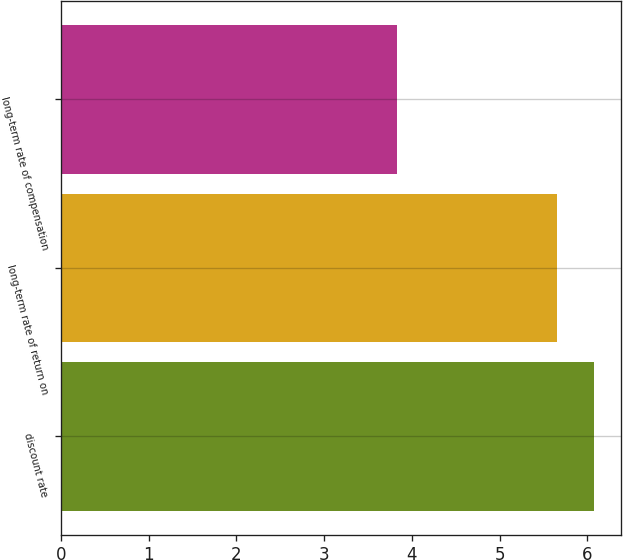Convert chart to OTSL. <chart><loc_0><loc_0><loc_500><loc_500><bar_chart><fcel>discount rate<fcel>long-term rate of return on<fcel>long-term rate of compensation<nl><fcel>6.08<fcel>5.65<fcel>3.83<nl></chart> 